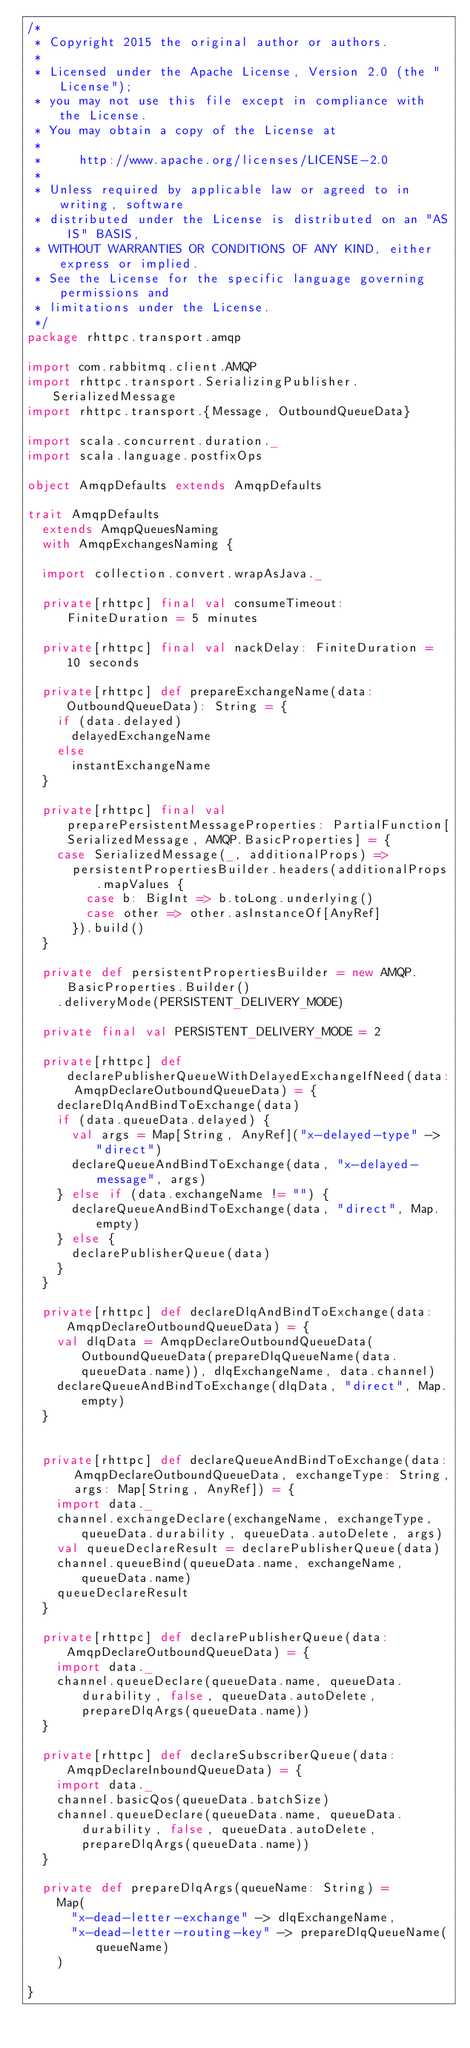<code> <loc_0><loc_0><loc_500><loc_500><_Scala_>/*
 * Copyright 2015 the original author or authors.
 *
 * Licensed under the Apache License, Version 2.0 (the "License");
 * you may not use this file except in compliance with the License.
 * You may obtain a copy of the License at
 *
 *     http://www.apache.org/licenses/LICENSE-2.0
 *
 * Unless required by applicable law or agreed to in writing, software
 * distributed under the License is distributed on an "AS IS" BASIS,
 * WITHOUT WARRANTIES OR CONDITIONS OF ANY KIND, either express or implied.
 * See the License for the specific language governing permissions and
 * limitations under the License.
 */
package rhttpc.transport.amqp

import com.rabbitmq.client.AMQP
import rhttpc.transport.SerializingPublisher.SerializedMessage
import rhttpc.transport.{Message, OutboundQueueData}

import scala.concurrent.duration._
import scala.language.postfixOps

object AmqpDefaults extends AmqpDefaults

trait AmqpDefaults
  extends AmqpQueuesNaming
  with AmqpExchangesNaming {

  import collection.convert.wrapAsJava._

  private[rhttpc] final val consumeTimeout: FiniteDuration = 5 minutes
  
  private[rhttpc] final val nackDelay: FiniteDuration = 10 seconds

  private[rhttpc] def prepareExchangeName(data: OutboundQueueData): String = {
    if (data.delayed)
      delayedExchangeName
    else
      instantExchangeName
  }

  private[rhttpc] final val preparePersistentMessageProperties: PartialFunction[SerializedMessage, AMQP.BasicProperties] = {
    case SerializedMessage(_, additionalProps) =>
      persistentPropertiesBuilder.headers(additionalProps.mapValues {
        case b: BigInt => b.toLong.underlying()
        case other => other.asInstanceOf[AnyRef]
      }).build()
  }

  private def persistentPropertiesBuilder = new AMQP.BasicProperties.Builder()
    .deliveryMode(PERSISTENT_DELIVERY_MODE)

  private final val PERSISTENT_DELIVERY_MODE = 2

  private[rhttpc] def declarePublisherQueueWithDelayedExchangeIfNeed(data: AmqpDeclareOutboundQueueData) = {
    declareDlqAndBindToExchange(data)
    if (data.queueData.delayed) {
      val args = Map[String, AnyRef]("x-delayed-type" -> "direct")
      declareQueueAndBindToExchange(data, "x-delayed-message", args)
    } else if (data.exchangeName != "") {
      declareQueueAndBindToExchange(data, "direct", Map.empty)
    } else {
      declarePublisherQueue(data)
    }
  }

  private[rhttpc] def declareDlqAndBindToExchange(data: AmqpDeclareOutboundQueueData) = {
    val dlqData = AmqpDeclareOutboundQueueData(OutboundQueueData(prepareDlqQueueName(data.queueData.name)), dlqExchangeName, data.channel)
    declareQueueAndBindToExchange(dlqData, "direct", Map.empty)
  }


  private[rhttpc] def declareQueueAndBindToExchange(data: AmqpDeclareOutboundQueueData, exchangeType: String, args: Map[String, AnyRef]) = {
    import data._
    channel.exchangeDeclare(exchangeName, exchangeType, queueData.durability, queueData.autoDelete, args)
    val queueDeclareResult = declarePublisherQueue(data)
    channel.queueBind(queueData.name, exchangeName, queueData.name)
    queueDeclareResult
  }

  private[rhttpc] def declarePublisherQueue(data: AmqpDeclareOutboundQueueData) = {
    import data._
    channel.queueDeclare(queueData.name, queueData.durability, false, queueData.autoDelete, prepareDlqArgs(queueData.name))
  }

  private[rhttpc] def declareSubscriberQueue(data: AmqpDeclareInboundQueueData) = {
    import data._
    channel.basicQos(queueData.batchSize)
    channel.queueDeclare(queueData.name, queueData.durability, false, queueData.autoDelete, prepareDlqArgs(queueData.name))
  }

  private def prepareDlqArgs(queueName: String) =
    Map(
      "x-dead-letter-exchange" -> dlqExchangeName,
      "x-dead-letter-routing-key" -> prepareDlqQueueName(queueName)
    )

}</code> 